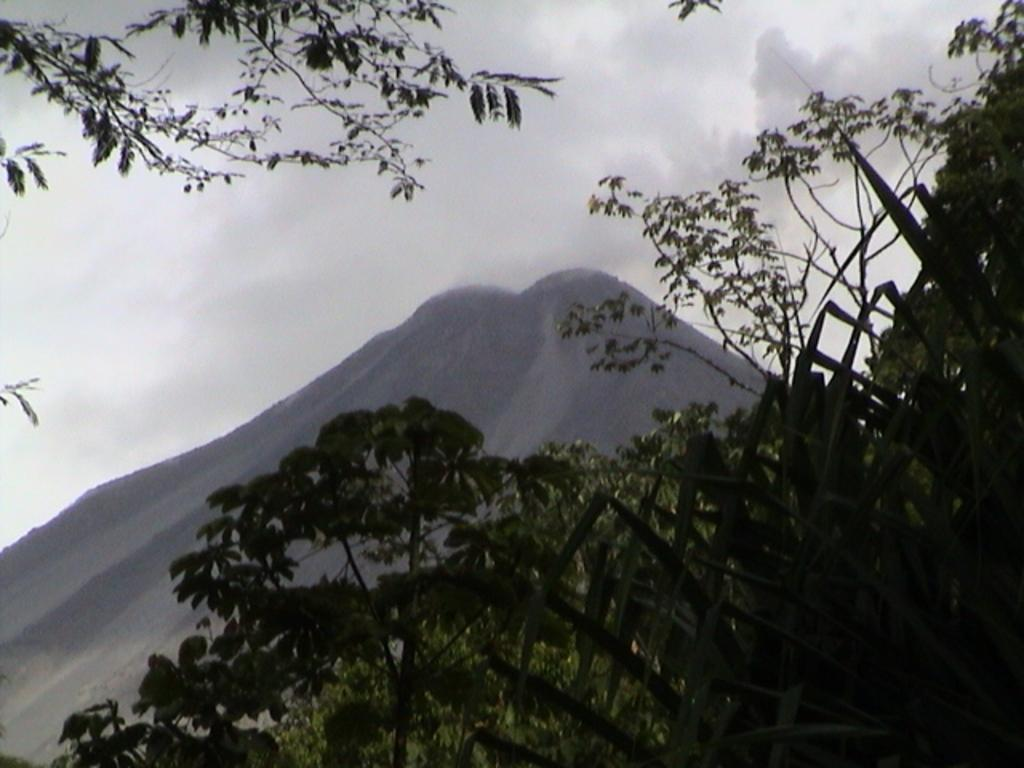What types of vegetation are present at the bottom of the image? There are plants and trees at the bottom of the image. Where is another tree located in the image? There is a tree in the left top corner of the image. What can be seen in the distance in the background of the image? There is a mountain in the background of the image. What is visible in the sky in the background of the image? There are clouds in the sky in the background of the image. Can you see the frame of the image? The frame of the image is not visible in the image itself, as it is the border surrounding the image. Is there a spy observing the scene in the image? There is no indication of a spy or any person in the image, so it cannot be determined from the image. 